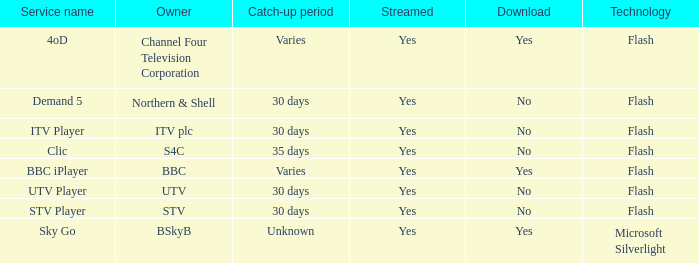What is the Catch-up period for UTV? 30 days. 